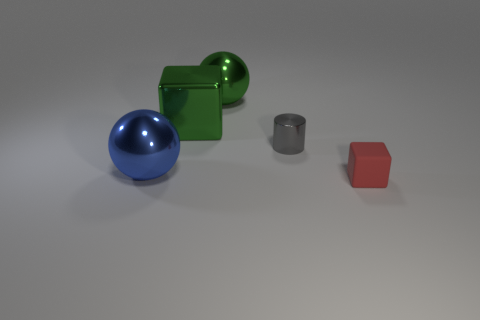How many spheres are on the left side of the cube left of the gray thing? There is one sphere on the left side of the green cube, which is positioned to the left of the gray cylinder. 